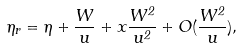Convert formula to latex. <formula><loc_0><loc_0><loc_500><loc_500>\eta _ { r } = \eta + \frac { W } { u } + x \frac { W ^ { 2 } } { u ^ { 2 } } + O ( \frac { W ^ { 2 } } { u } ) ,</formula> 